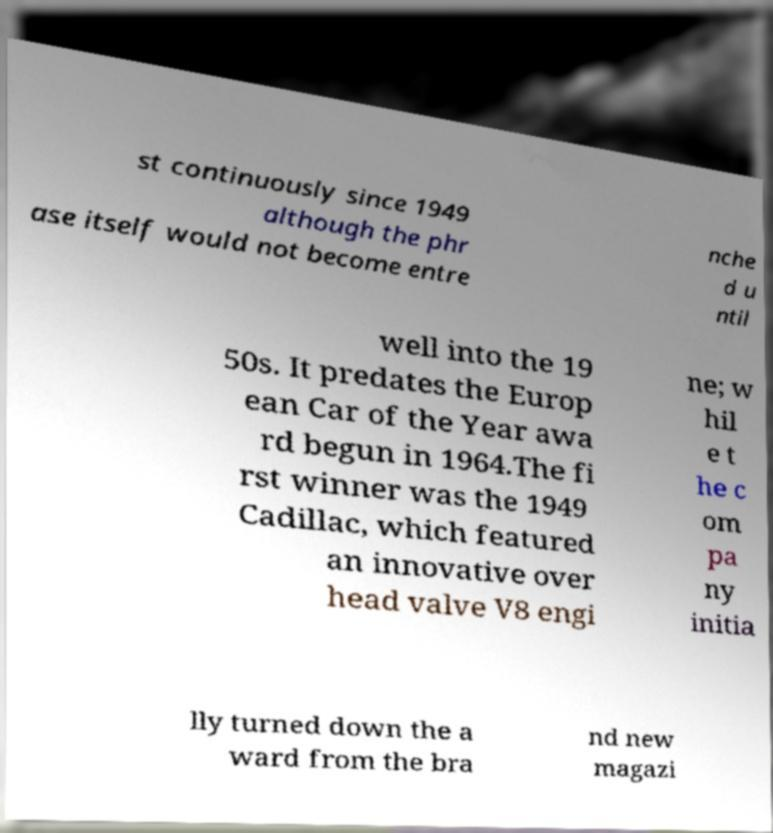Please read and relay the text visible in this image. What does it say? st continuously since 1949 although the phr ase itself would not become entre nche d u ntil well into the 19 50s. It predates the Europ ean Car of the Year awa rd begun in 1964.The fi rst winner was the 1949 Cadillac, which featured an innovative over head valve V8 engi ne; w hil e t he c om pa ny initia lly turned down the a ward from the bra nd new magazi 